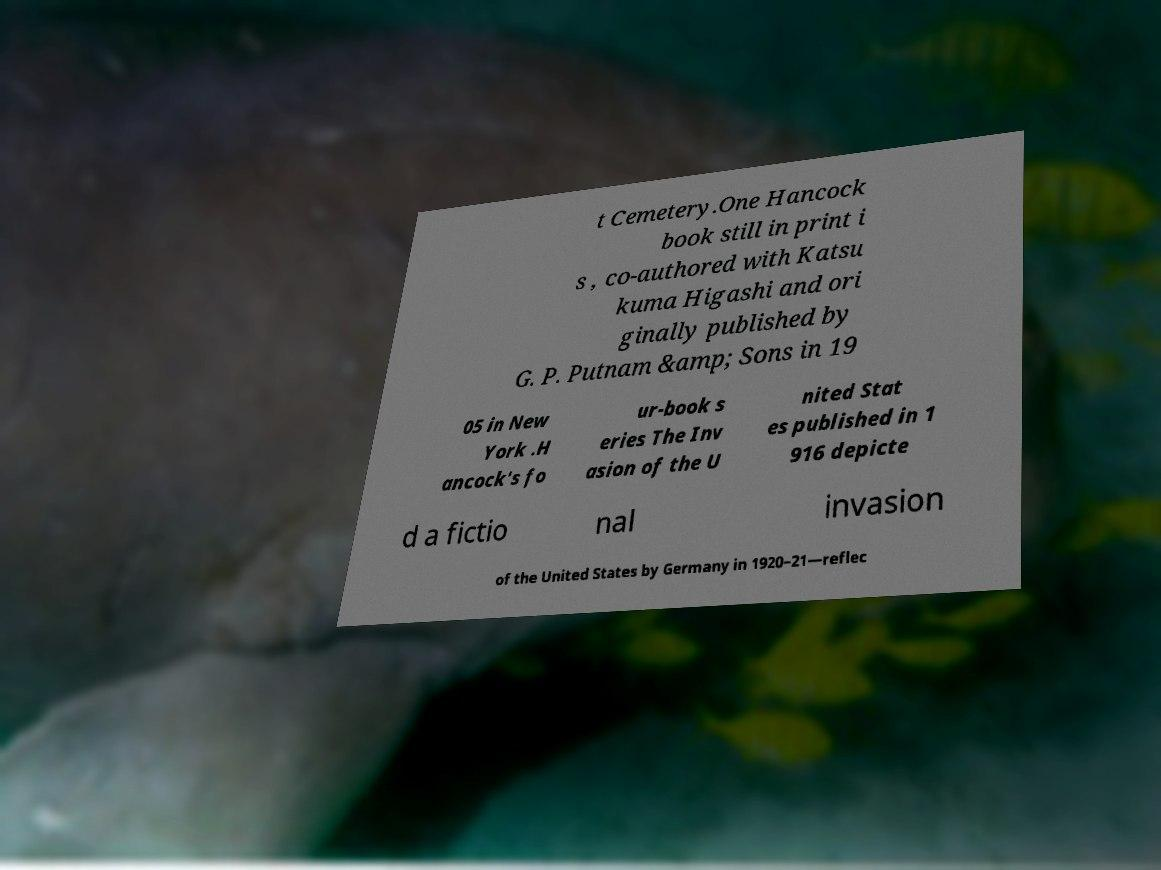For documentation purposes, I need the text within this image transcribed. Could you provide that? t Cemetery.One Hancock book still in print i s , co-authored with Katsu kuma Higashi and ori ginally published by G. P. Putnam &amp; Sons in 19 05 in New York .H ancock's fo ur-book s eries The Inv asion of the U nited Stat es published in 1 916 depicte d a fictio nal invasion of the United States by Germany in 1920–21—reflec 